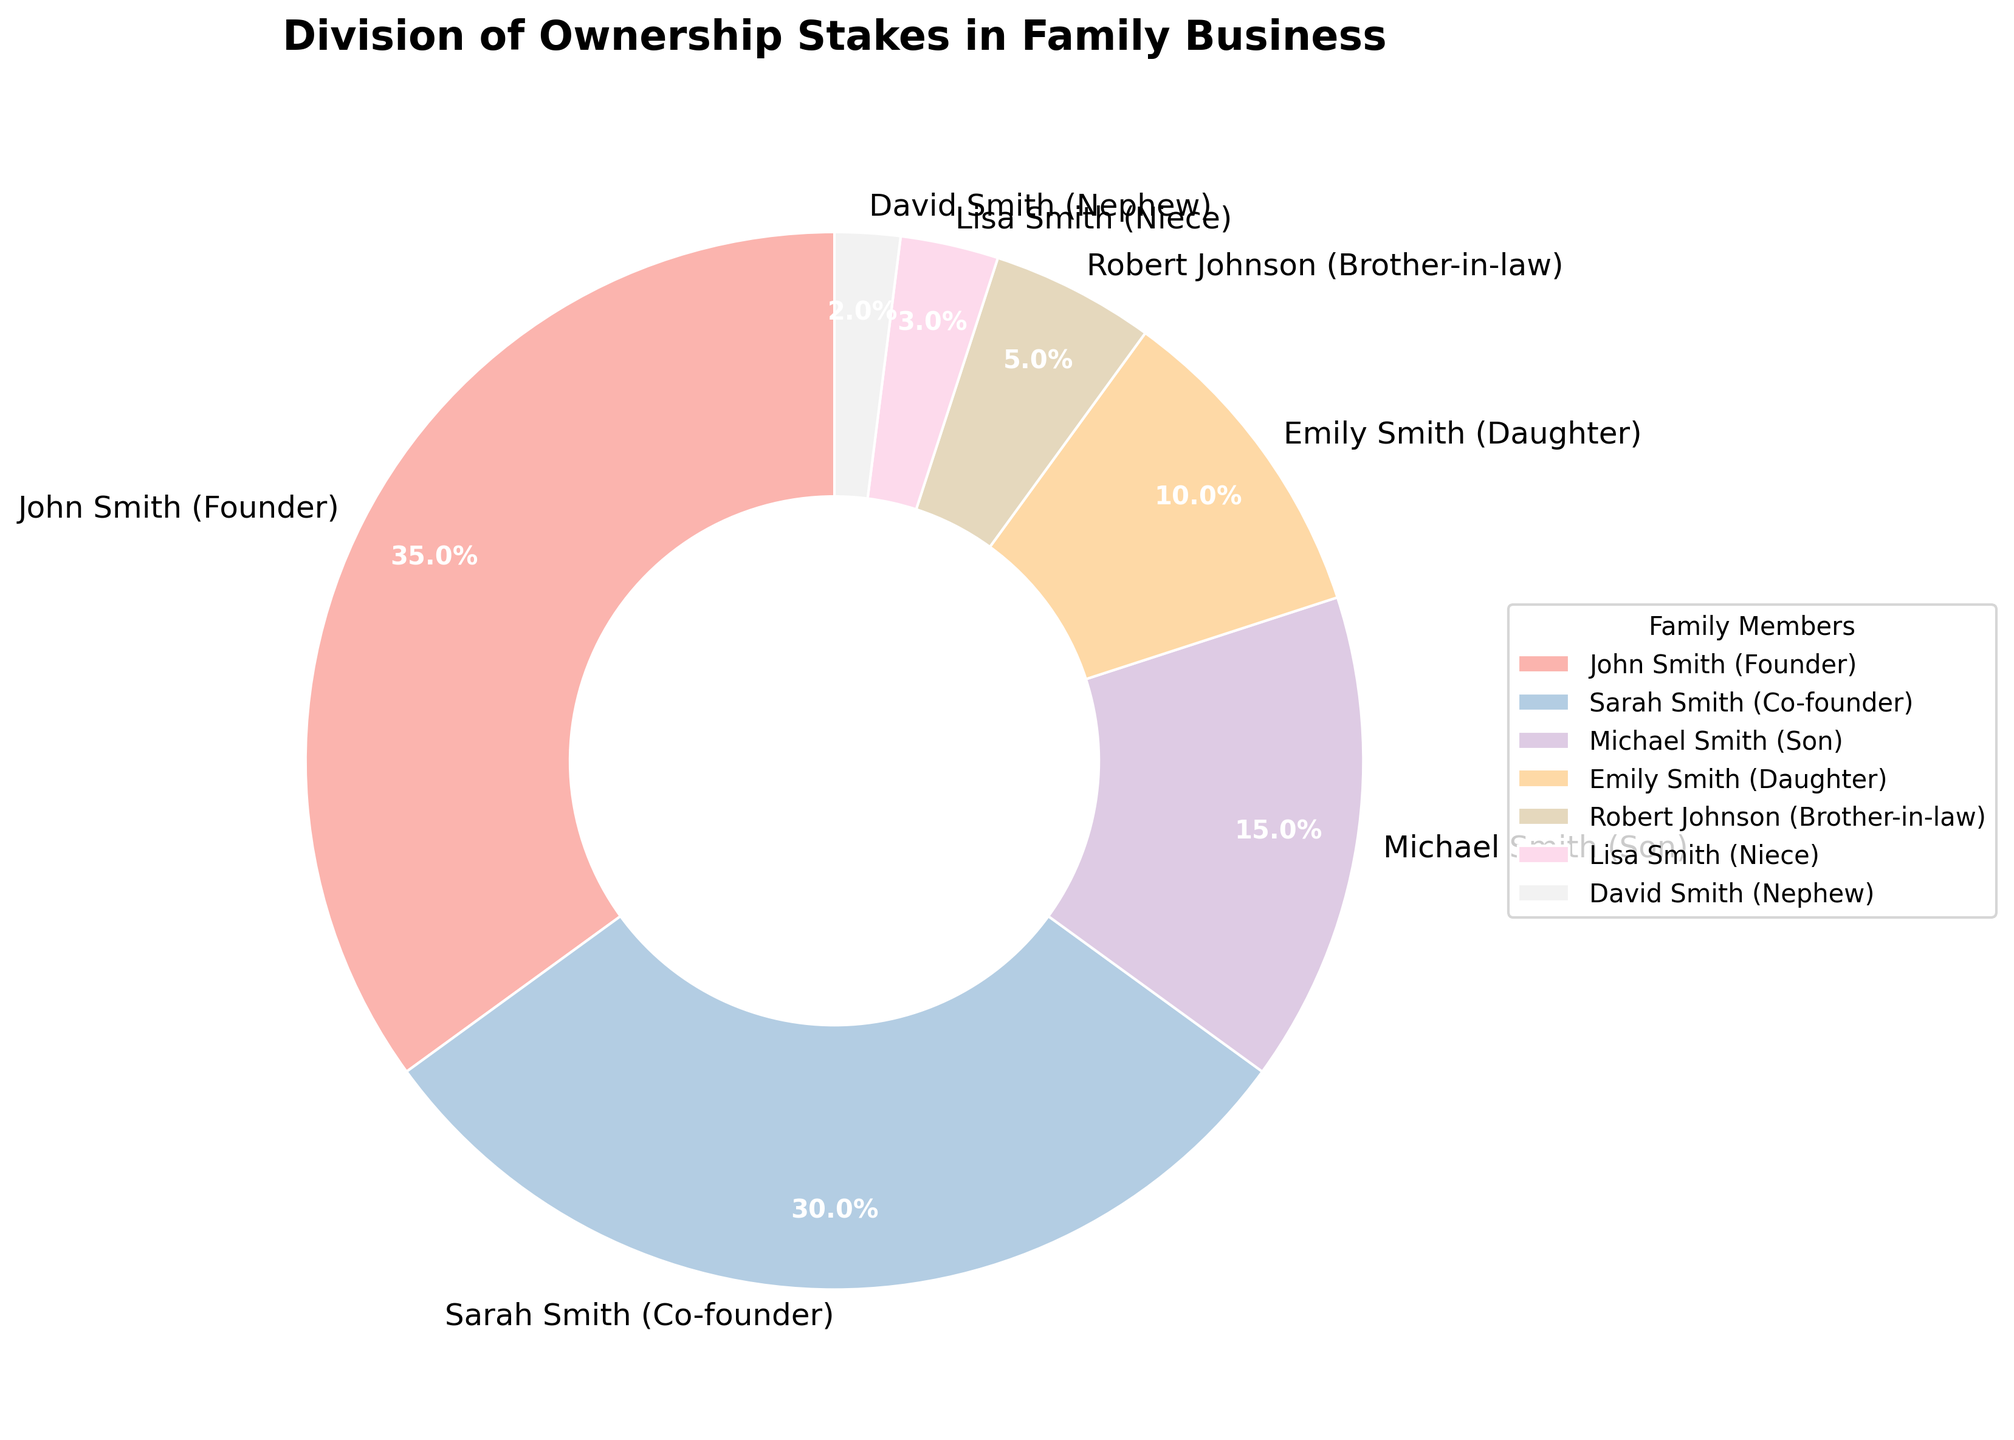What is the total percentage of ownership by John Smith and Sarah Smith? John Smith holds 35% and Sarah Smith holds 30%. Summing these values gives 35 + 30.
Answer: 65% Who has a larger ownership stake, Michael Smith or Emily Smith? By examining the figure, we see that Michael Smith has a 15% stake, while Emily Smith has a 10% stake. Therefore, Michael Smith's stake is larger.
Answer: Michael Smith What is the combined ownership percentage of the three smallest stakeholders? The smallest stakeholders are Lisa Smith (3%), David Smith (2%), and Robert Johnson (5%). Adding these values gives 3 + 2 + 5.
Answer: 10% Which stakeholder holds the smallest ownership percentage, and what is it? According to the pie chart, David Smith holds the smallest ownership percentage at 2%.
Answer: David Smith, 2% What percentage of the company is controlled by the children of John and Sarah Smith? Michael Smith has 15% and Emily Smith has 10%. Summing these values gives 15 + 10.
Answer: 25% How much larger is the ownership stake of John Smith compared to Robert Johnson? John Smith has 35% ownership while Robert Johnson has 5%. The difference is 35 - 5.
Answer: 30% What percentage of ownership is shared by family members who are not direct descendants of the founders? These members are Robert Johnson (5%), Lisa Smith (3%), and David Smith (2%). Adding these values gives 5 + 3 + 2.
Answer: 10% Between Sarah Smith and Michael Smith, who has a smaller stake, and by how much? Sarah Smith has 30% while Michael Smith has 15%. The difference between them is 30 - 15.
Answer: Michael Smith, 15% Which two stakeholders combined have a larger ownership percentage than John Smith alone? Combining Sarah Smith (30%) and Michael Smith (15%) results in 30 + 15 = 45%, which is larger than John Smith’s 35%.
Answer: Sarah Smith and Michael Smith What is the difference in percentage between the highest and lowest ownership stakes? The highest ownership stake is John Smith’s 35% and the lowest is David Smith’s 2%. The difference is 35 - 2.
Answer: 33% 